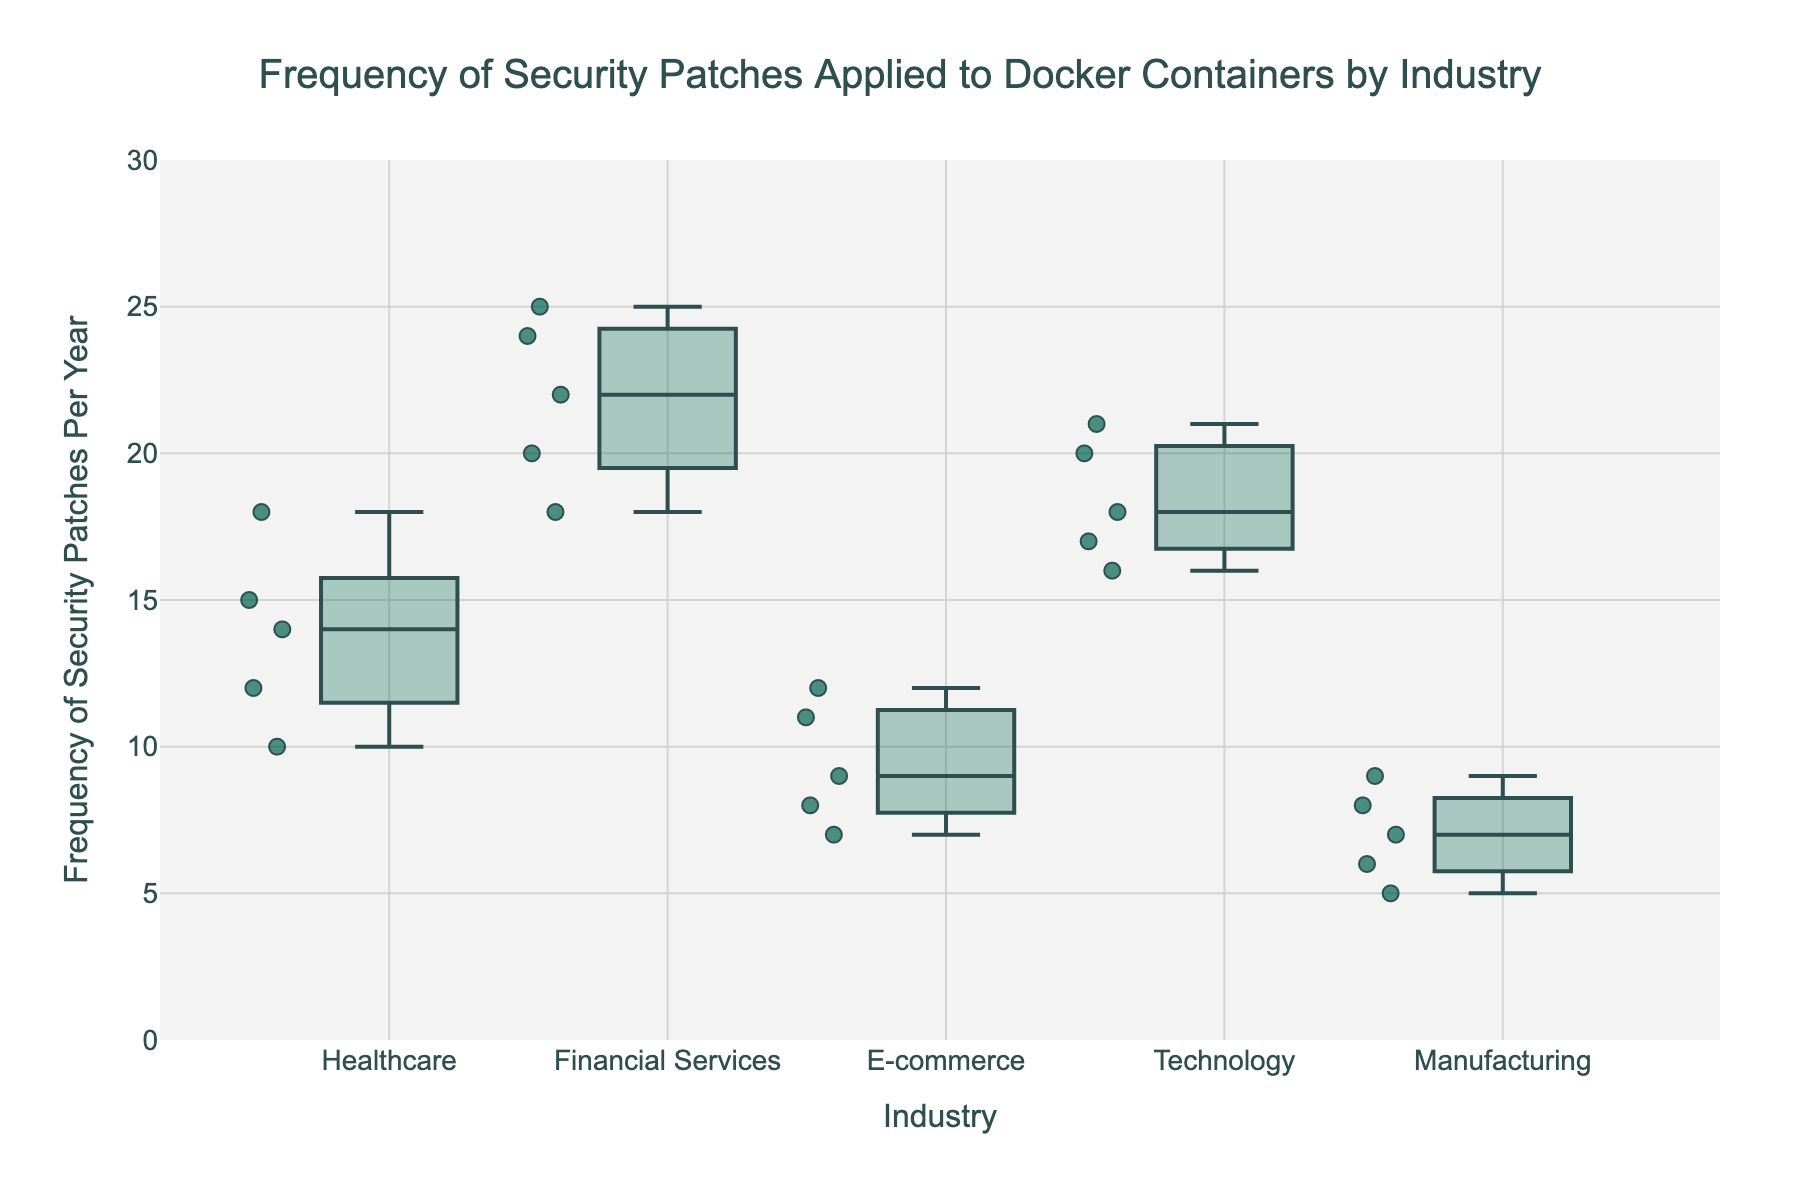What is the title of the figure? The title is located at the top of the figure, centered and labeled in a larger font size. It states the main subject of the data visualization.
Answer: Frequency of Security Patches Applied to Docker Containers by Industry What is the range of the y-axis? The y-axis range is determined by observing the smallest and largest tick marks on the y-axis.
Answer: 0 to 30 Which industry has the highest median frequency of security patches? The median is the line inside the box of each industry. The highest median is found visually by comparing the positions of these lines.
Answer: Financial Services Which industry has the most outliers? Outliers are individual points outside the whiskers of the boxes. The industry with the most outliers can be identified by counting these points.
Answer: Healthcare What is the median frequency of security patches for the Technology industry? Find the median for the Technology industry by locating the line inside the Technology box, which represents the middle value of the data set.
Answer: 18 Which industry has the lowest minimum value of frequency of patches? The minimum value appears at the end of the lower whisker. The lowest minimum value can be found by comparing the positions of these whiskers across industries.
Answer: Manufacturing How does the interquartile range (IQR) of Healthcare compare to E-commerce? The IQR is the range between the first quartile (bottom line of the box) and the third quartile (top line of the box). Calculate and compare these ranges for Healthcare and E-commerce.
Answer: Healthcare IQR is greater than E-commerce IQR Which industry shows the widest spread in the frequency of patches applied? The spread or range is the distance between the minimum and maximum values, indicated by the whiskers of the box plot.
Answer: Financial Services Are there any industries with overlapping interquartile ranges? Overlapping IQRs occur when the boxes of different industries intersect. Visually inspect if any boxes overlap.
Answer: Yes, Technology and Healthcare What is the third quartile value for the Manufacturing industry? The third quartile is the top line of the box. Identify this value for Manufacturing by locating the top of its box.
Answer: 8 